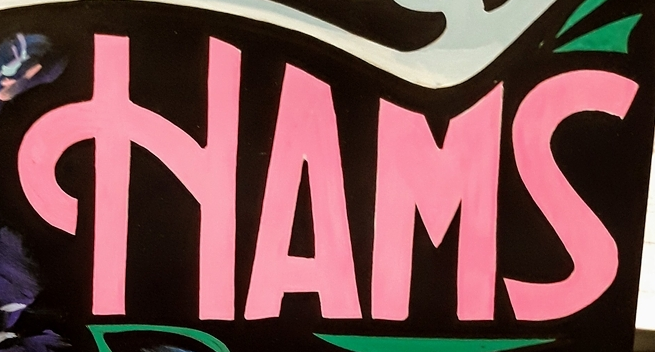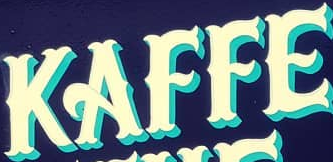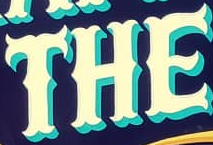Transcribe the words shown in these images in order, separated by a semicolon. HAMS; KAFFE; THE 